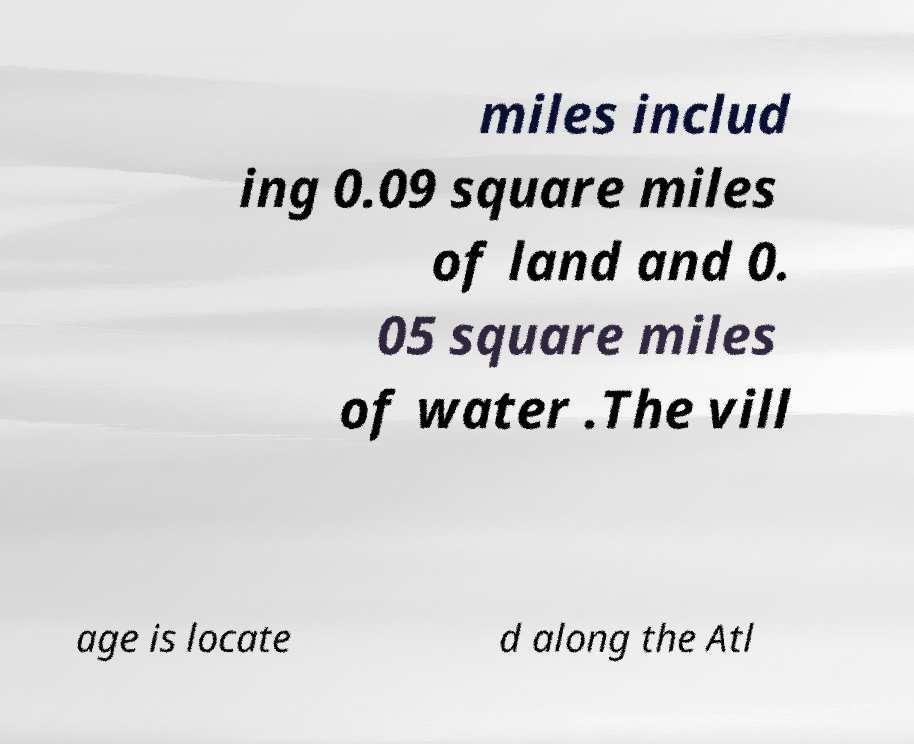Could you assist in decoding the text presented in this image and type it out clearly? miles includ ing 0.09 square miles of land and 0. 05 square miles of water .The vill age is locate d along the Atl 